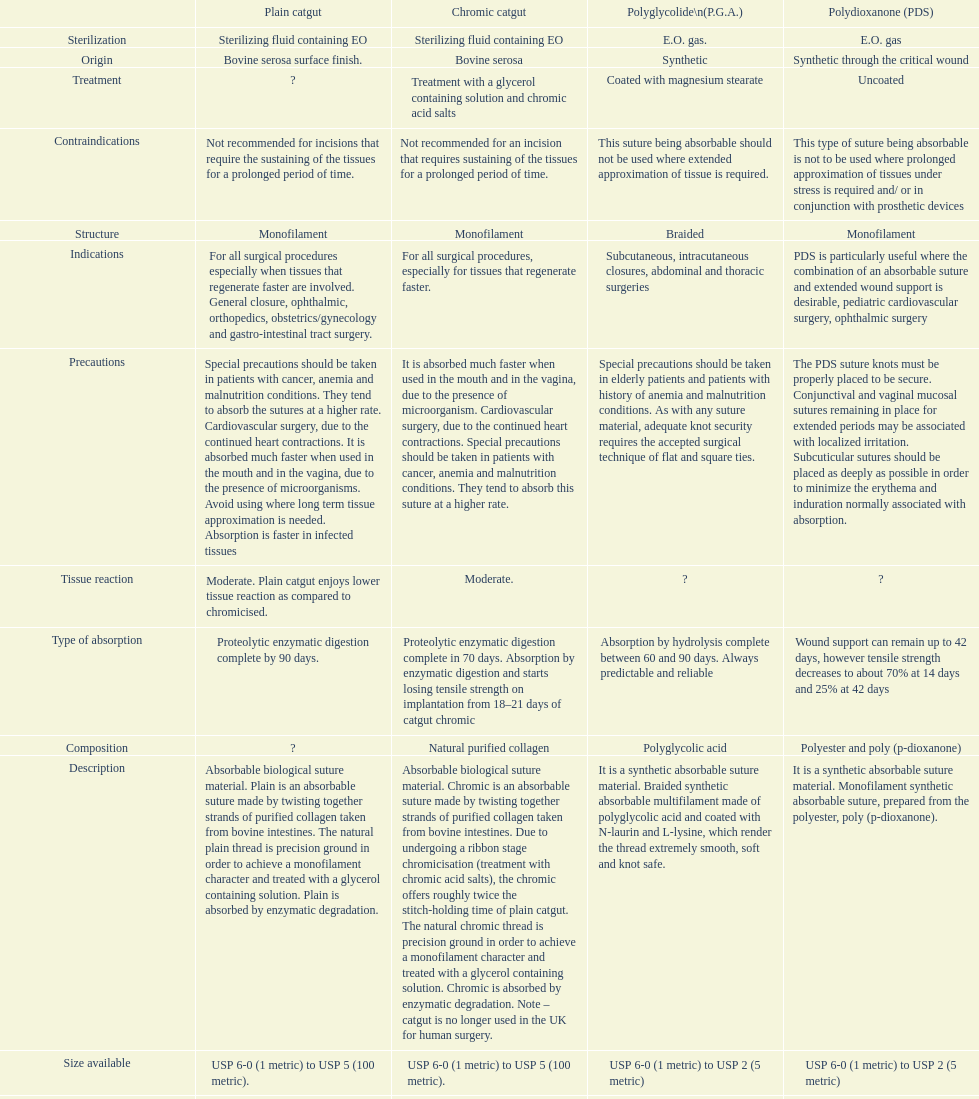What type of sutures are no longer used in the u.k. for human surgery? Chromic catgut. 